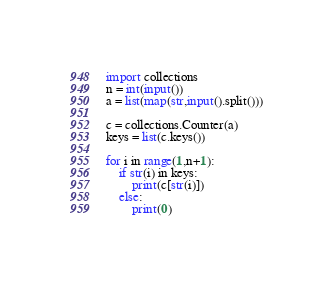Convert code to text. <code><loc_0><loc_0><loc_500><loc_500><_Python_>import collections
n = int(input())
a = list(map(str,input().split()))
 
c = collections.Counter(a)
keys = list(c.keys())
 
for i in range(1,n+1):
    if str(i) in keys:
        print(c[str(i)])
    else:
        print(0)</code> 